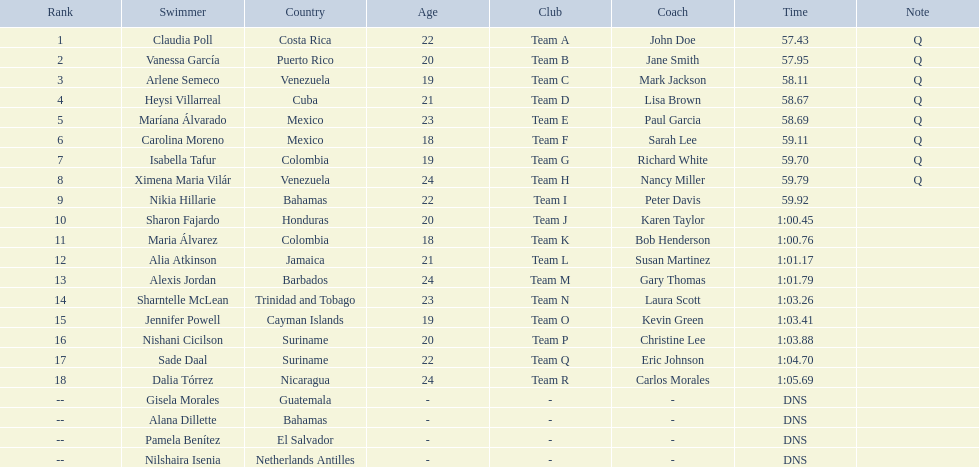Who were the swimmers at the 2006 central american and caribbean games - women's 100 metre freestyle? Claudia Poll, Vanessa García, Arlene Semeco, Heysi Villarreal, Maríana Álvarado, Carolina Moreno, Isabella Tafur, Ximena Maria Vilár, Nikia Hillarie, Sharon Fajardo, Maria Álvarez, Alia Atkinson, Alexis Jordan, Sharntelle McLean, Jennifer Powell, Nishani Cicilson, Sade Daal, Dalia Tórrez, Gisela Morales, Alana Dillette, Pamela Benítez, Nilshaira Isenia. Of these which were from cuba? Heysi Villarreal. 